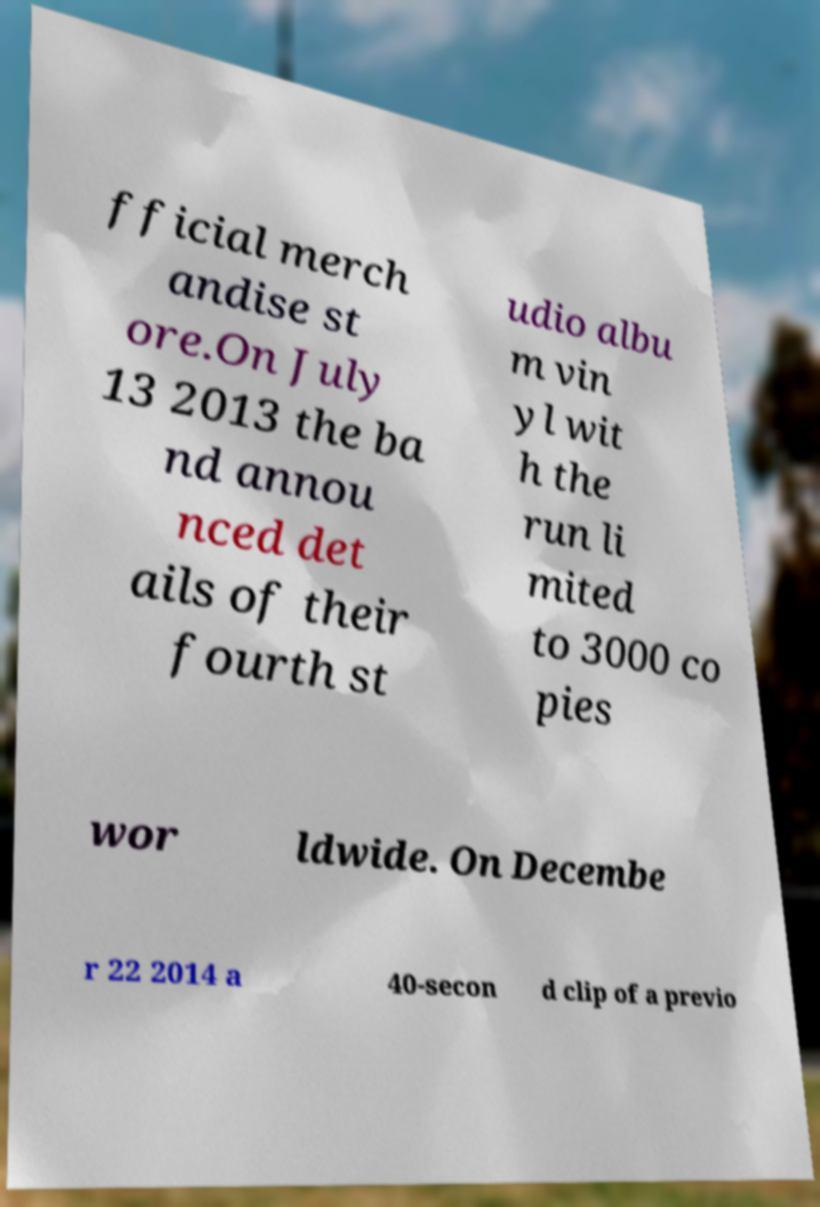Could you extract and type out the text from this image? fficial merch andise st ore.On July 13 2013 the ba nd annou nced det ails of their fourth st udio albu m vin yl wit h the run li mited to 3000 co pies wor ldwide. On Decembe r 22 2014 a 40-secon d clip of a previo 